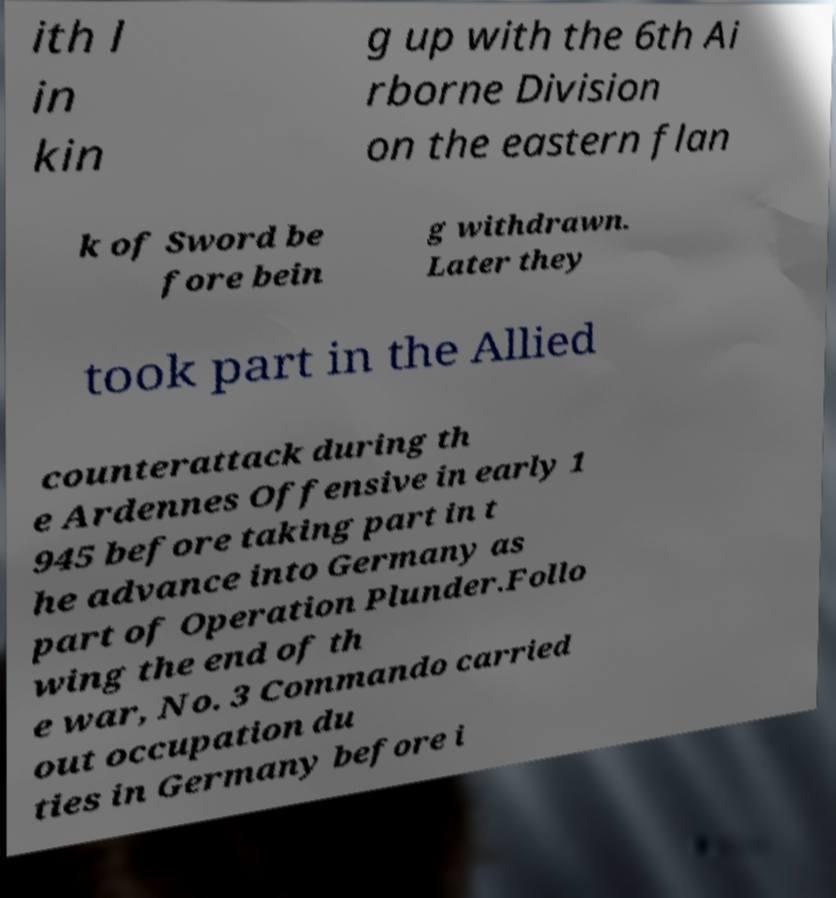Can you read and provide the text displayed in the image?This photo seems to have some interesting text. Can you extract and type it out for me? ith l in kin g up with the 6th Ai rborne Division on the eastern flan k of Sword be fore bein g withdrawn. Later they took part in the Allied counterattack during th e Ardennes Offensive in early 1 945 before taking part in t he advance into Germany as part of Operation Plunder.Follo wing the end of th e war, No. 3 Commando carried out occupation du ties in Germany before i 